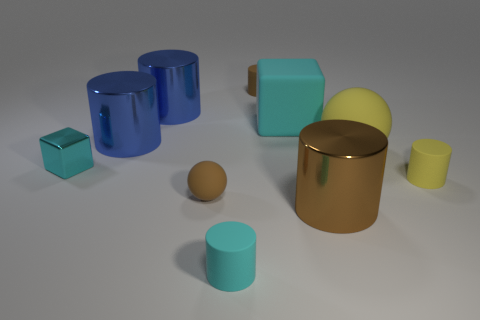How many cyan cubes must be subtracted to get 1 cyan cubes? 1 Subtract all cyan cylinders. How many cylinders are left? 5 Subtract all big brown metal cylinders. How many cylinders are left? 5 Subtract 1 cylinders. How many cylinders are left? 5 Subtract all brown balls. Subtract all blue blocks. How many balls are left? 1 Subtract all cubes. How many objects are left? 8 Add 8 big cyan things. How many big cyan things are left? 9 Add 5 blue cylinders. How many blue cylinders exist? 7 Subtract 0 yellow cubes. How many objects are left? 10 Subtract all blue shiny cylinders. Subtract all big brown objects. How many objects are left? 7 